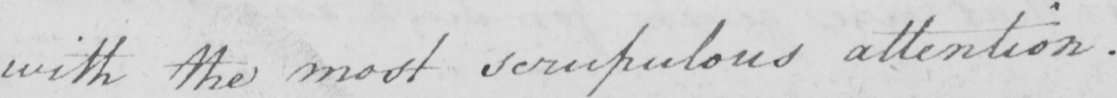Transcribe the text shown in this historical manuscript line. with the most scrupulous attention . 